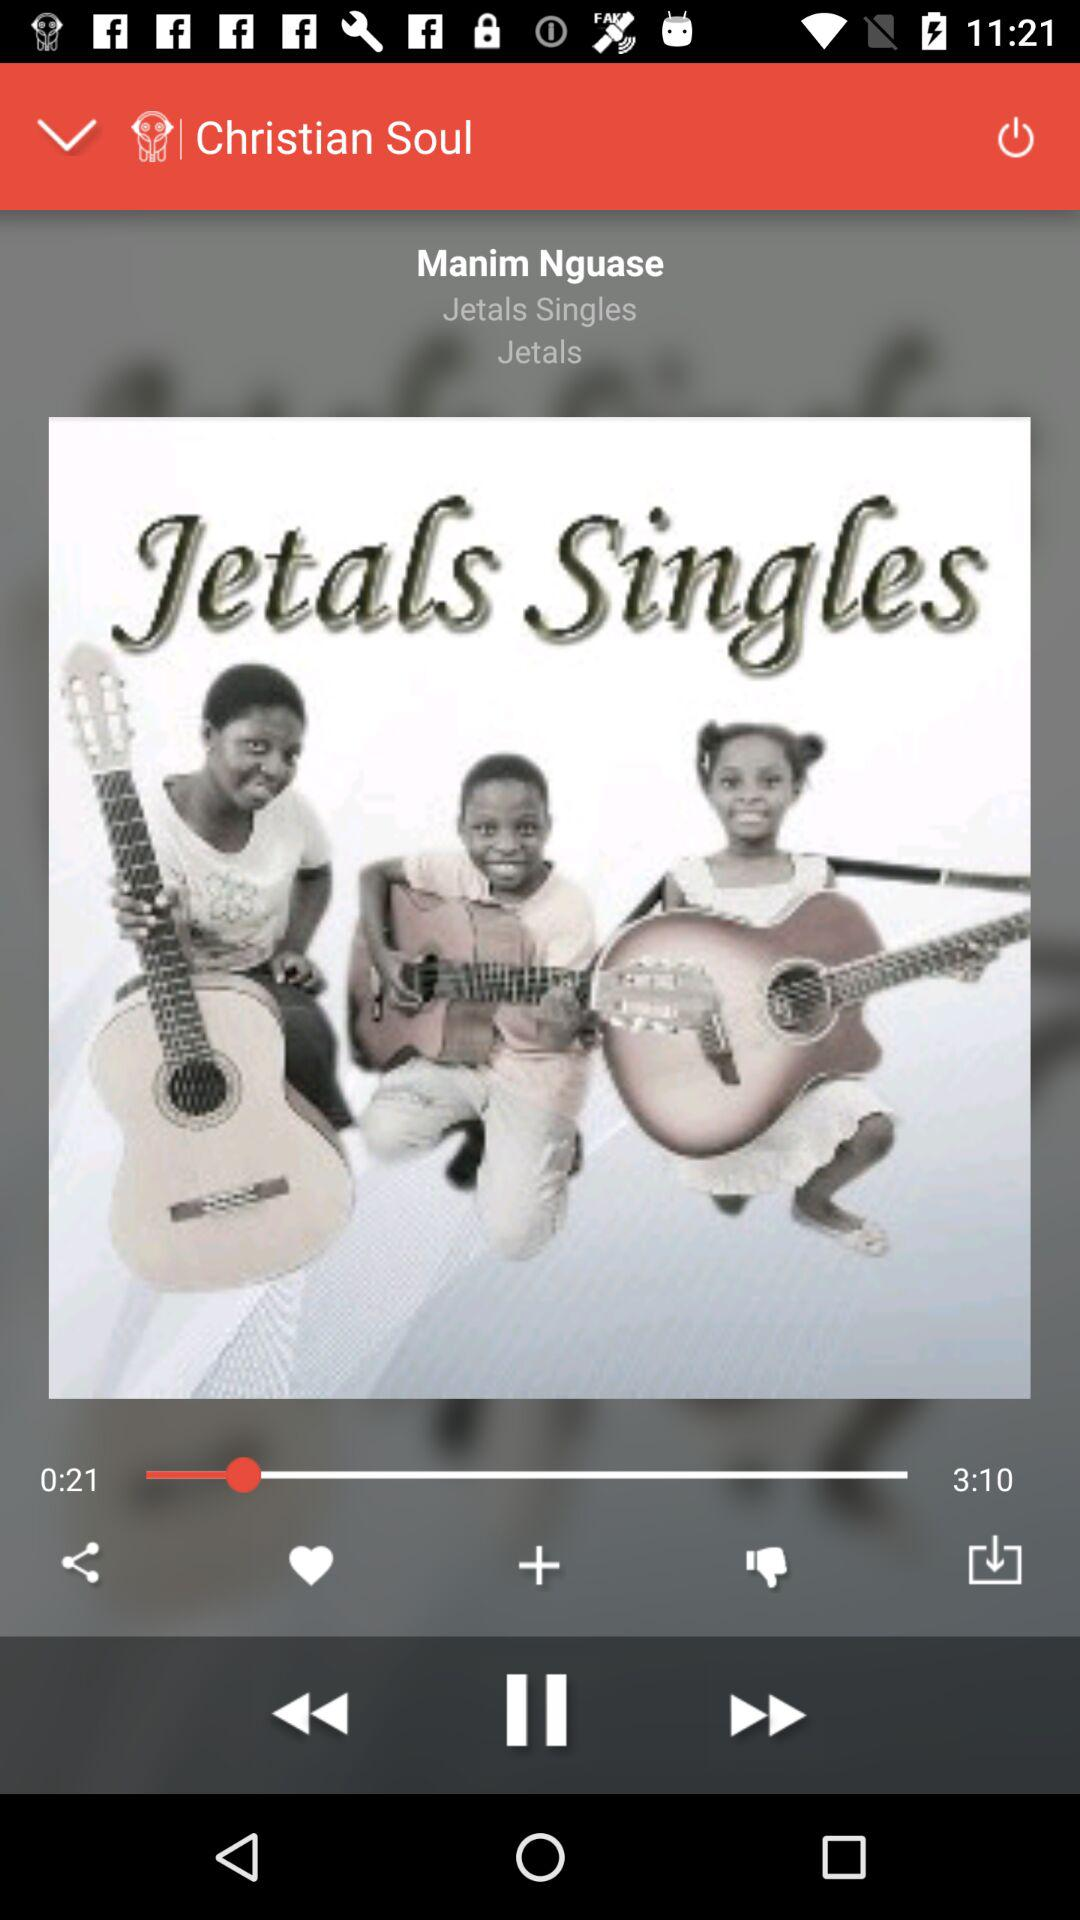How long is the audio? The audio is 3 minutes and 10 seconds long. 